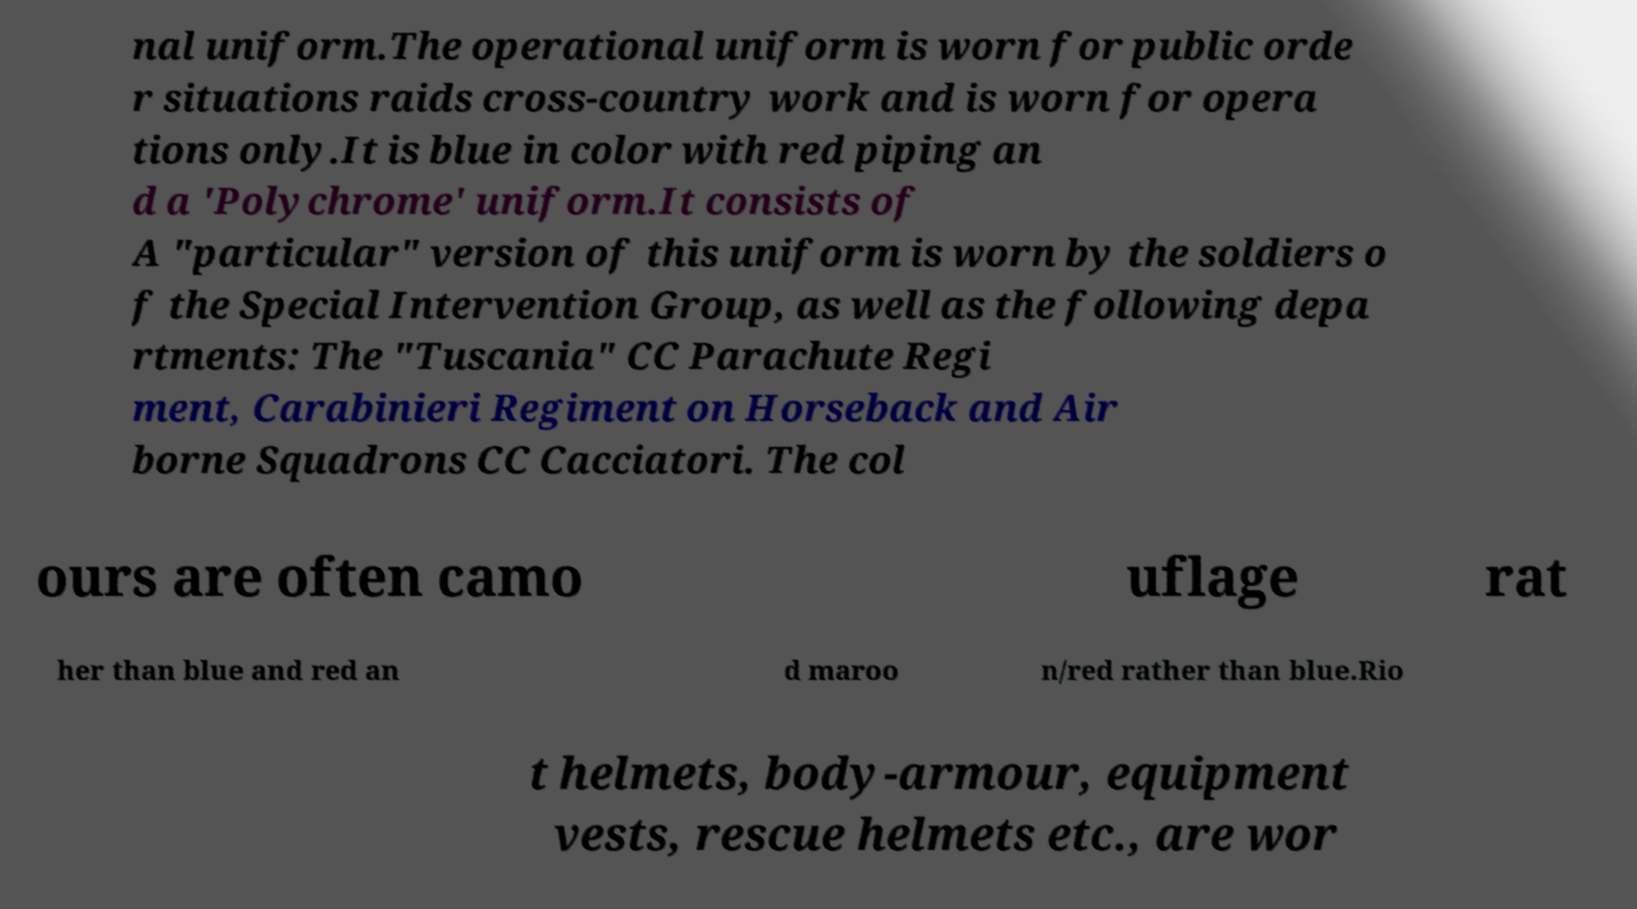Could you assist in decoding the text presented in this image and type it out clearly? nal uniform.The operational uniform is worn for public orde r situations raids cross-country work and is worn for opera tions only.It is blue in color with red piping an d a 'Polychrome' uniform.It consists of A "particular" version of this uniform is worn by the soldiers o f the Special Intervention Group, as well as the following depa rtments: The "Tuscania" CC Parachute Regi ment, Carabinieri Regiment on Horseback and Air borne Squadrons CC Cacciatori. The col ours are often camo uflage rat her than blue and red an d maroo n/red rather than blue.Rio t helmets, body-armour, equipment vests, rescue helmets etc., are wor 